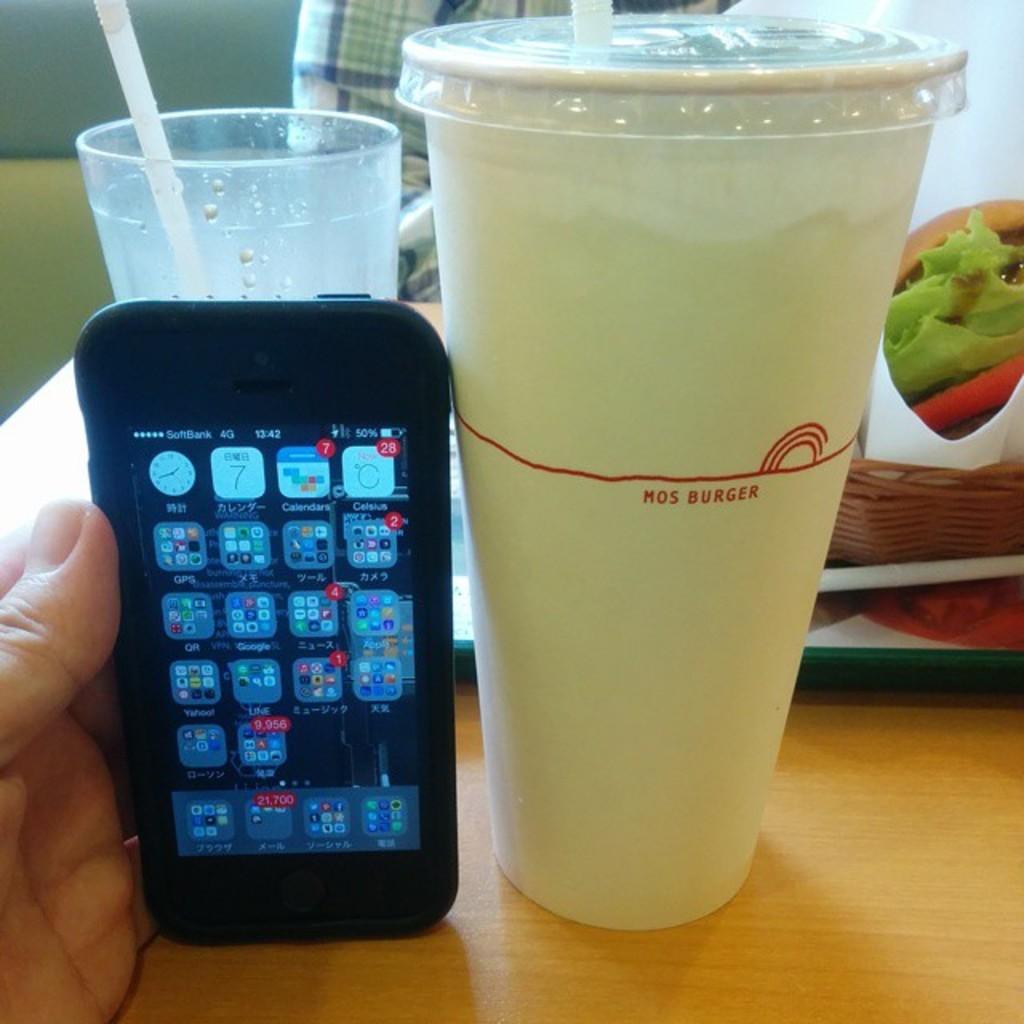What's the name on the cup?
Your response must be concise. Mos burger. What type of smart phone does he have?
Your answer should be compact. Iphone. 